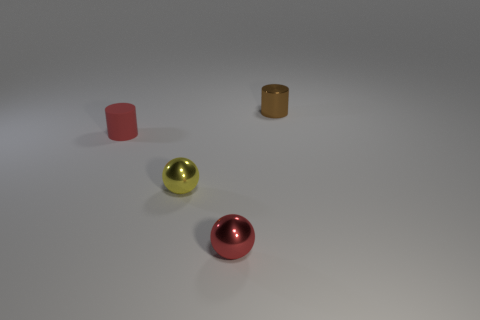Can you describe the lighting in the scene and how it affects the appearance of the objects? The lighting in the scene appears to be soft and diffused, coming from above, casting subtle shadows directly underneath the objects. This type of lighting softens the appearance of the objects, reduces harsh reflections, and highlights their shapes and colors. 